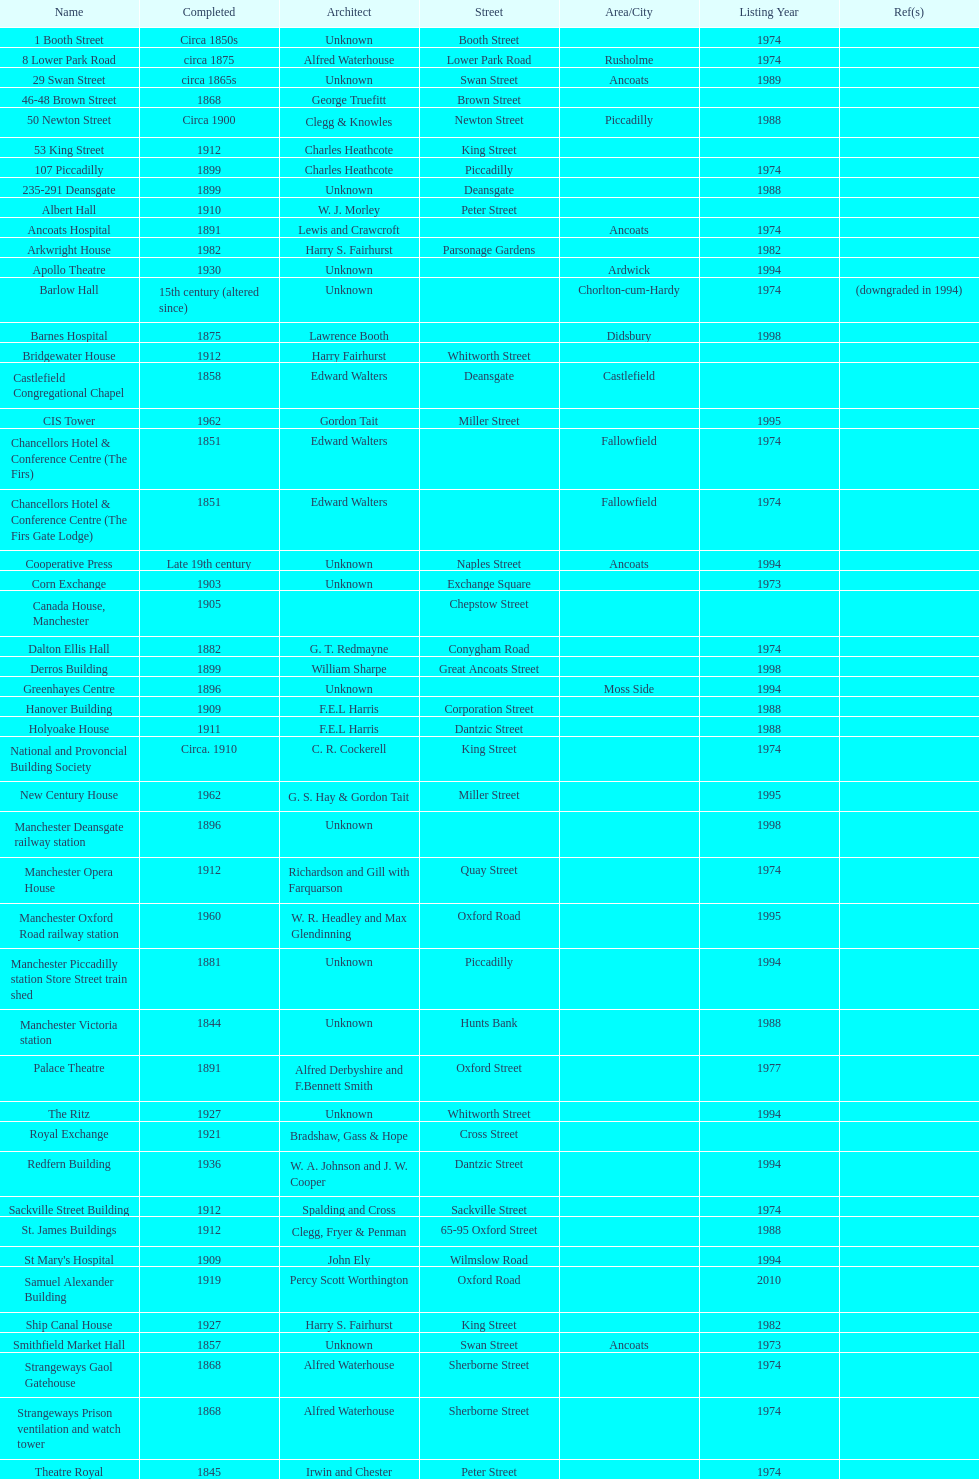How many buildings has the same year of listing as 1974? 15. 